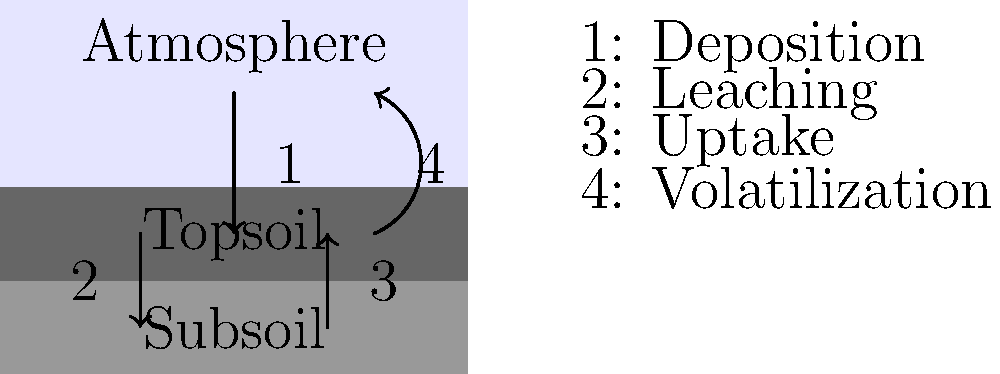As a supplier of eco-friendly fertilizers, understanding the soil nutrient cycle is crucial. In the diagram, which process represents the movement of nutrients from the atmosphere to the topsoil, and how might this process be enhanced to reduce the need for synthetic fertilizers in sustainable farming practices? To answer this question, let's analyze the soil nutrient cycle diagram step-by-step:

1. The diagram shows four main processes in the soil nutrient cycle:
   - Process 1: Downward arrow from atmosphere to topsoil
   - Process 2: Downward arrow from topsoil to subsoil
   - Process 3: Upward arrow from subsoil to topsoil
   - Process 4: Upward curved arrow from topsoil to atmosphere

2. The process representing the movement of nutrients from the atmosphere to the topsoil is Process 1, labeled as "Deposition" in the legend.

3. Deposition can occur through various mechanisms:
   a) Wet deposition: Nutrients dissolved in rainwater or snow
   b) Dry deposition: Nutrients in dust particles settling on the soil surface
   c) Biological fixation: Nitrogen fixation by certain bacteria and legumes

4. To enhance this process and reduce the need for synthetic fertilizers:
   a) Promote cover cropping with legumes to increase nitrogen fixation
   b) Implement agroforestry practices to capture more atmospheric nutrients
   c) Encourage no-till or minimal tillage practices to preserve soil structure and beneficial microorganisms
   d) Use compost and organic mulches to increase soil organic matter, which helps retain deposited nutrients
   e) Plant buffer strips or hedgerows to capture airborne nutrients and prevent erosion

5. These practices align with sustainable farming by:
   - Reducing reliance on external inputs
   - Improving soil health and biodiversity
   - Enhancing natural nutrient cycling processes
   - Minimizing environmental impacts associated with synthetic fertilizers

By focusing on enhancing the natural deposition process and implementing these sustainable practices, farmers can reduce their dependence on synthetic fertilizers while maintaining soil fertility and crop productivity.
Answer: Deposition; enhanced by cover cropping, agroforestry, no-till practices, composting, and buffer strips. 